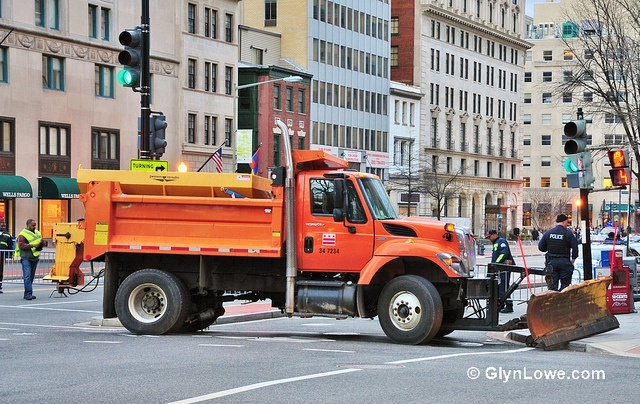Describe the objects in this image and their specific colors. I can see truck in blue, black, red, gray, and orange tones, people in blue, black, navy, gray, and darkgray tones, traffic light in blue, black, gray, and darkgray tones, people in blue, black, navy, darkblue, and yellow tones, and traffic light in blue, black, gray, purple, and turquoise tones in this image. 